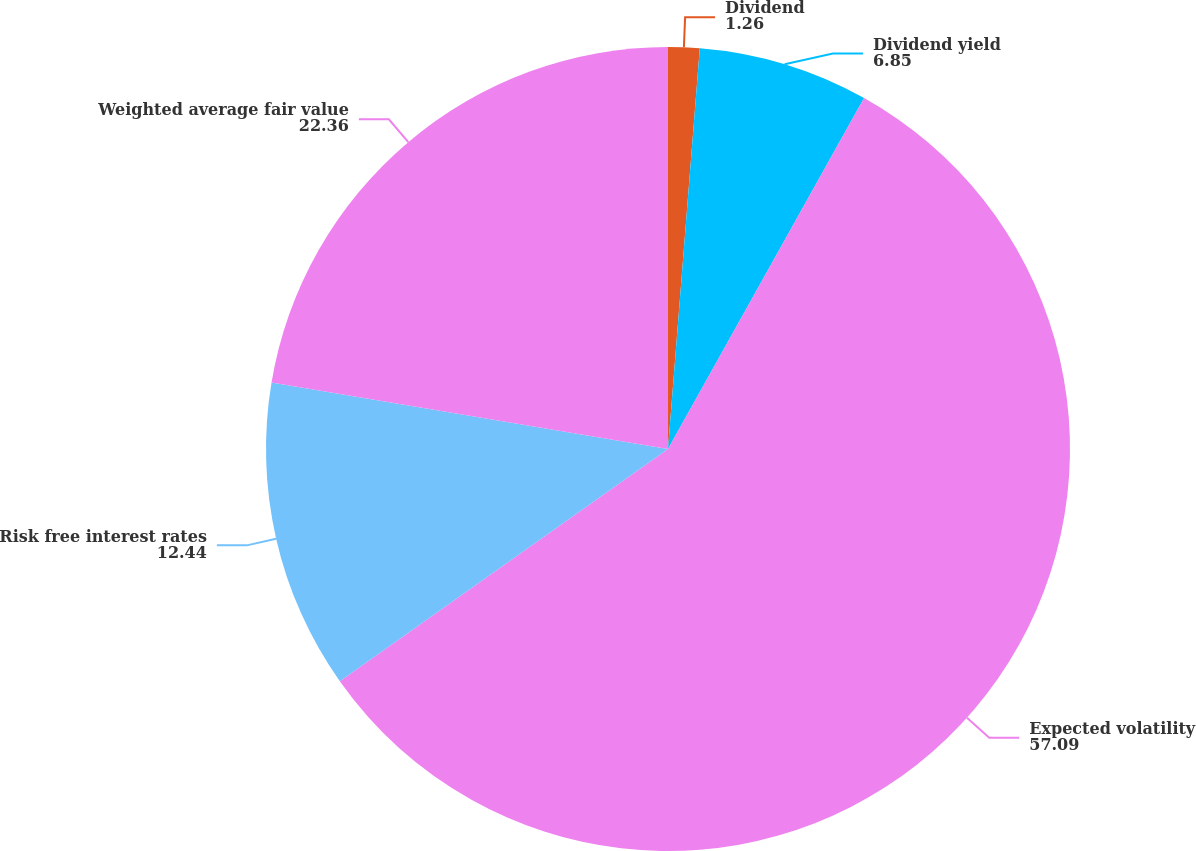Convert chart. <chart><loc_0><loc_0><loc_500><loc_500><pie_chart><fcel>Dividend<fcel>Dividend yield<fcel>Expected volatility<fcel>Risk free interest rates<fcel>Weighted average fair value<nl><fcel>1.26%<fcel>6.85%<fcel>57.09%<fcel>12.44%<fcel>22.36%<nl></chart> 